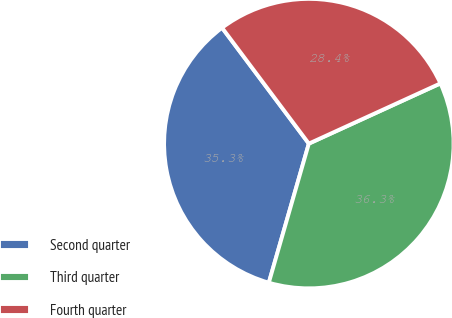Convert chart. <chart><loc_0><loc_0><loc_500><loc_500><pie_chart><fcel>Second quarter<fcel>Third quarter<fcel>Fourth quarter<nl><fcel>35.31%<fcel>36.29%<fcel>28.4%<nl></chart> 